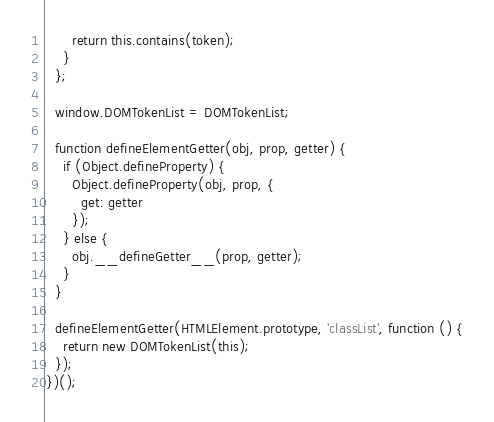Convert code to text. <code><loc_0><loc_0><loc_500><loc_500><_JavaScript_>      return this.contains(token);
    }
  };

  window.DOMTokenList = DOMTokenList;

  function defineElementGetter(obj, prop, getter) {
    if (Object.defineProperty) {
      Object.defineProperty(obj, prop, {
        get: getter
      });
    } else {
      obj.__defineGetter__(prop, getter);
    }
  }

  defineElementGetter(HTMLElement.prototype, 'classList', function () {
    return new DOMTokenList(this);
  });
})();
</code> 